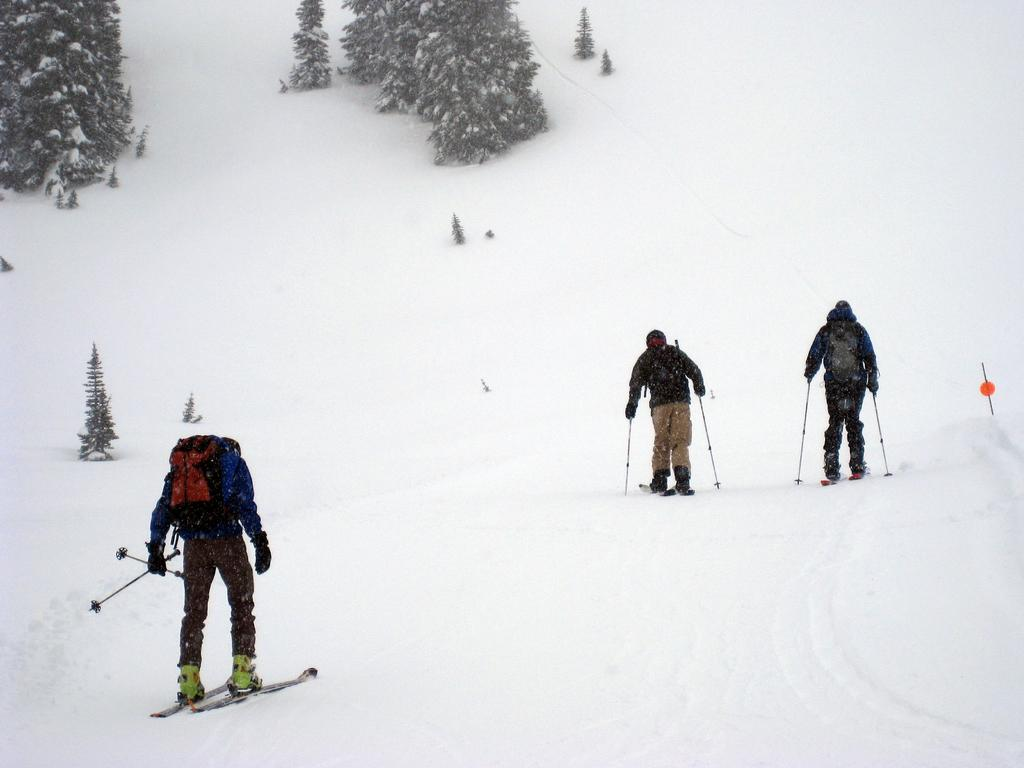What is the condition of the land in the image? The land is covered with snow. What type of vegetation is visible in the image? There are trees with snow in the image. What activity are the people engaged in? The people are riding skateboards. What are the people wearing on their backs? The people are wearing bags. What objects are the people holding in their hands? The people are holding sticks. Can you hear the whistle of the wind in the image? There is no mention of wind or a whistle in the image, so it cannot be determined if the whistle of the wind can be heard. 